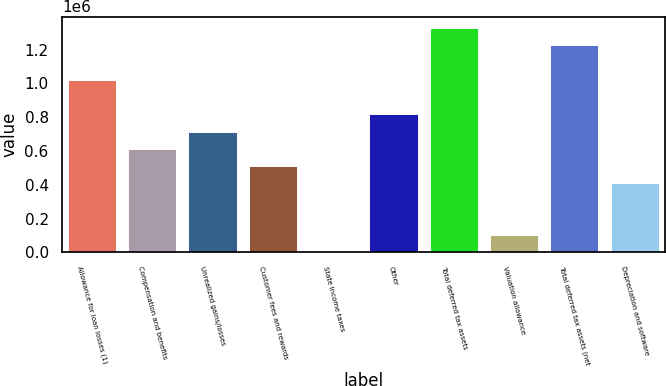Convert chart to OTSL. <chart><loc_0><loc_0><loc_500><loc_500><bar_chart><fcel>Allowance for loan losses (1)<fcel>Compensation and benefits<fcel>Unrealized gains/losses<fcel>Customer fees and rewards<fcel>State income taxes<fcel>Other<fcel>Total deferred tax assets<fcel>Valuation allowance<fcel>Total deferred tax assets (net<fcel>Depreciation and software<nl><fcel>1.0222e+06<fcel>613318<fcel>715538<fcel>511099<fcel>3.24<fcel>817757<fcel>1.32885e+06<fcel>102222<fcel>1.22663e+06<fcel>408880<nl></chart> 